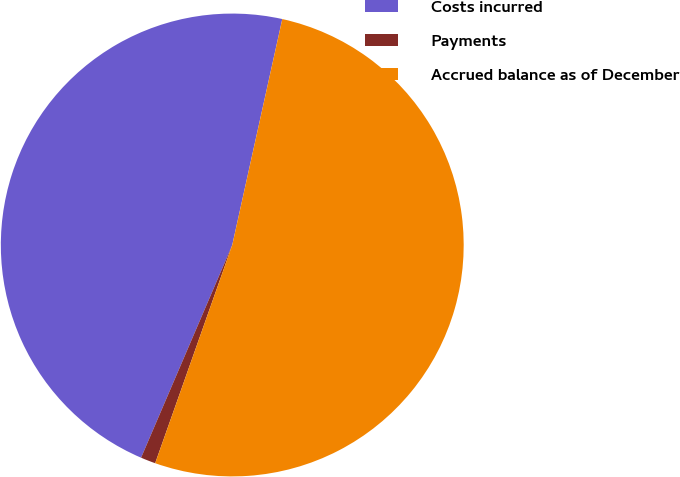<chart> <loc_0><loc_0><loc_500><loc_500><pie_chart><fcel>Costs incurred<fcel>Payments<fcel>Accrued balance as of December<nl><fcel>47.02%<fcel>1.04%<fcel>51.93%<nl></chart> 